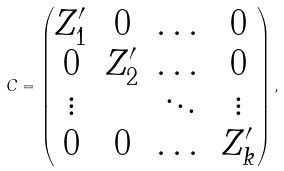<formula> <loc_0><loc_0><loc_500><loc_500>C = \begin{pmatrix} Z _ { 1 } ^ { \prime } & 0 & \dots & 0 \\ 0 & Z _ { 2 } ^ { \prime } & \dots & 0 \\ \vdots & & \ddots & \vdots \\ 0 & 0 & \dots & Z _ { k } ^ { \prime } \\ \end{pmatrix} ,</formula> 